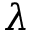Convert formula to latex. <formula><loc_0><loc_0><loc_500><loc_500>\lambda</formula> 